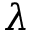Convert formula to latex. <formula><loc_0><loc_0><loc_500><loc_500>\lambda</formula> 